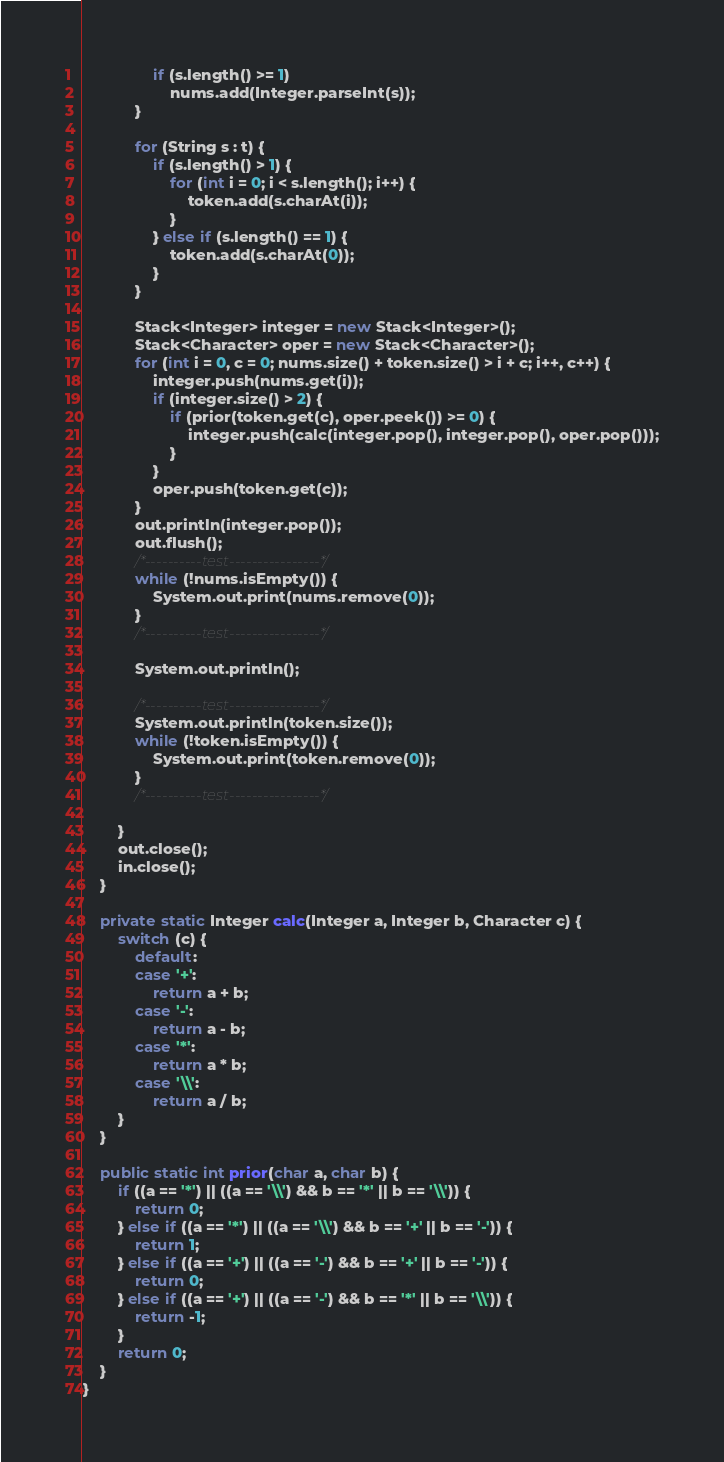<code> <loc_0><loc_0><loc_500><loc_500><_Java_>                if (s.length() >= 1)
                    nums.add(Integer.parseInt(s));
            }

            for (String s : t) {
                if (s.length() > 1) {
                    for (int i = 0; i < s.length(); i++) {
                        token.add(s.charAt(i));
                    }
                } else if (s.length() == 1) {
                    token.add(s.charAt(0));
                }
            }

            Stack<Integer> integer = new Stack<Integer>();
            Stack<Character> oper = new Stack<Character>();
            for (int i = 0, c = 0; nums.size() + token.size() > i + c; i++, c++) {
                integer.push(nums.get(i));
                if (integer.size() > 2) {
                    if (prior(token.get(c), oper.peek()) >= 0) {
                        integer.push(calc(integer.pop(), integer.pop(), oper.pop()));
                    }
                }
                oper.push(token.get(c));
            }
            out.println(integer.pop());
            out.flush();
            /*----------test----------------*/
            while (!nums.isEmpty()) {
                System.out.print(nums.remove(0));
            }
            /*----------test----------------*/

            System.out.println();

            /*----------test----------------*/
            System.out.println(token.size());
            while (!token.isEmpty()) {
                System.out.print(token.remove(0));
            }
            /*----------test----------------*/

        }
        out.close();
        in.close();
    }

    private static Integer calc(Integer a, Integer b, Character c) {
        switch (c) {
            default:
            case '+':
                return a + b;
            case '-':
                return a - b;
            case '*':
                return a * b;
            case '\\':
                return a / b;
        }
    }

    public static int prior(char a, char b) {
        if ((a == '*') || ((a == '\\') && b == '*' || b == '\\')) {
            return 0;
        } else if ((a == '*') || ((a == '\\') && b == '+' || b == '-')) {
            return 1;
        } else if ((a == '+') || ((a == '-') && b == '+' || b == '-')) {
            return 0;
        } else if ((a == '+') || ((a == '-') && b == '*' || b == '\\')) {
            return -1;
        }
        return 0;
    }
}
</code> 